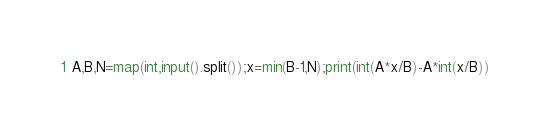Convert code to text. <code><loc_0><loc_0><loc_500><loc_500><_Python_>A,B,N=map(int,input().split());x=min(B-1,N);print(int(A*x/B)-A*int(x/B))</code> 